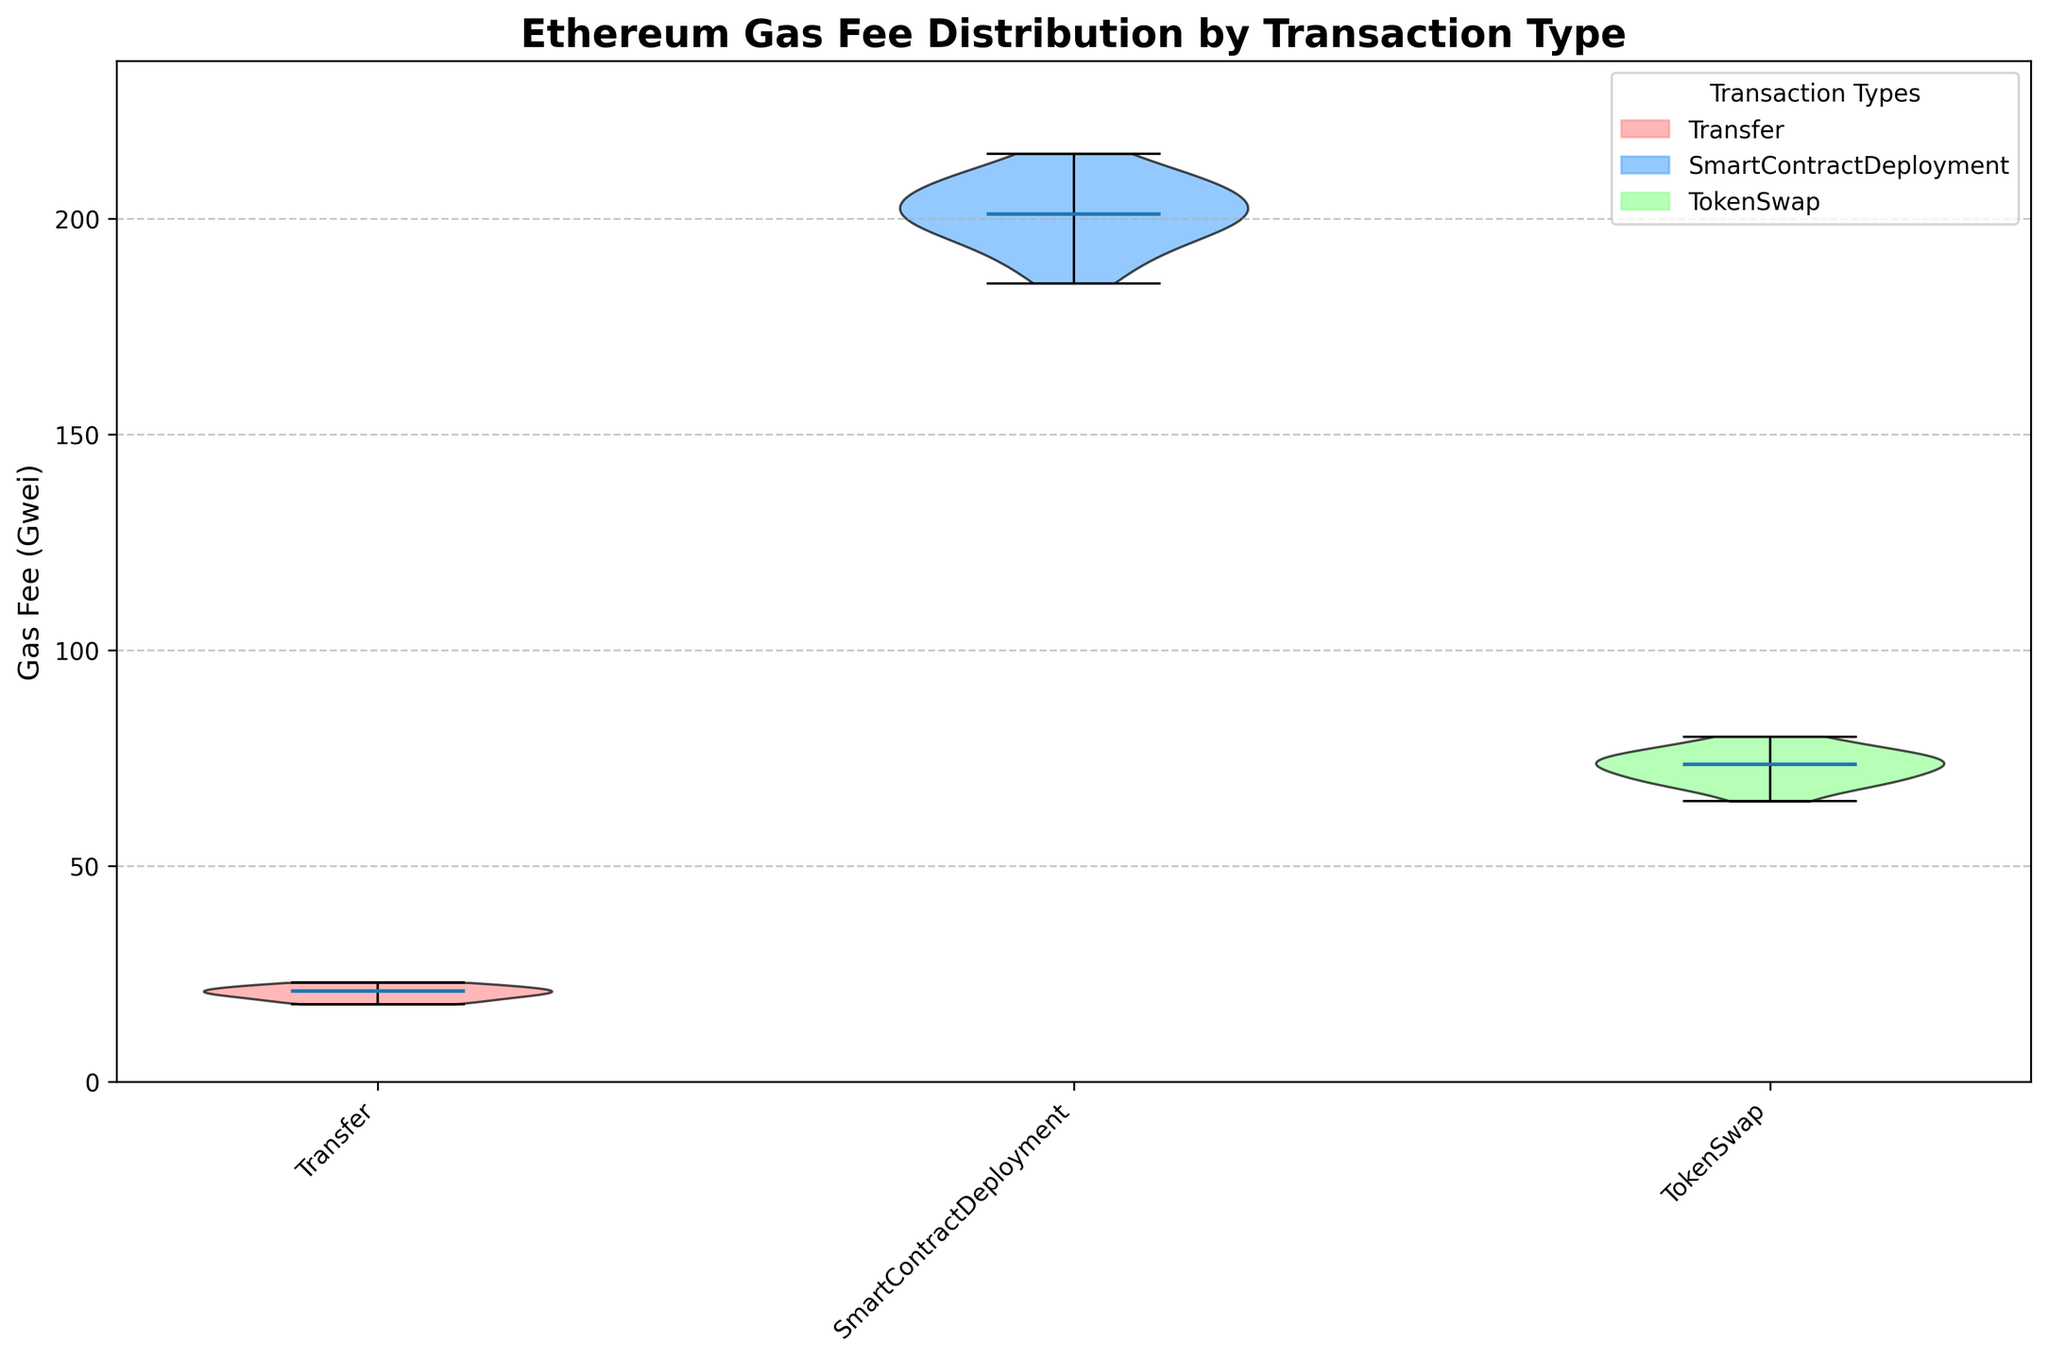What is the title of the violin chart? The title of the chart is displayed prominently at the top.
Answer: Ethereum Gas Fee Distribution by Transaction Type How many different transaction types are represented in the chart? The x-axis of the chart shows the different categories of transaction types.
Answer: Three Which transaction type has the widest distribution of gas fees? By examining the width of the violins, the transaction type with the widest violin plot represents the most distribution.
Answer: SmartContractDeployment What is the median gas fee for the Transfer transaction type? Look for the horizontal line within the violin for the Transfer transaction type; this line indicates the median.
Answer: 21 Gwei Which transaction type generally incurs the highest gas fees? Check which violin plot is positioned higher on the y-axis.
Answer: SmartContractDeployment How does the median gas fee for TokenSwap transactions compare to that for Transfer transactions? Compare the positions of the median lines within the respective violin plots.
Answer: Higher What is the range of gas fees for SmartContractDeployment transactions? The ends of the violin plot represent the range. Observing these points gives the minimum and maximum gas fees.
Answer: 185 to 215 Gwei Among the three transaction types, which one shows the most variability in gas fees? The width and spread of each violin can show how variable each transaction type is. The widest and most spread-out violin indicates the most variability.
Answer: SmartContractDeployment Is there a transaction type where the gas fee distribution is relatively consistent? A violin plot with a narrow width indicates less variability and more consistency.
Answer: Transfer What could be inferred about gas fee trends over time for TokenSwap transactions? Since a violin chart does not show time-series data directly, one should infer based on the overall shape and spread if there is any noticeable pattern in the distribution.
Answer: No clear trend, consistent distribution 